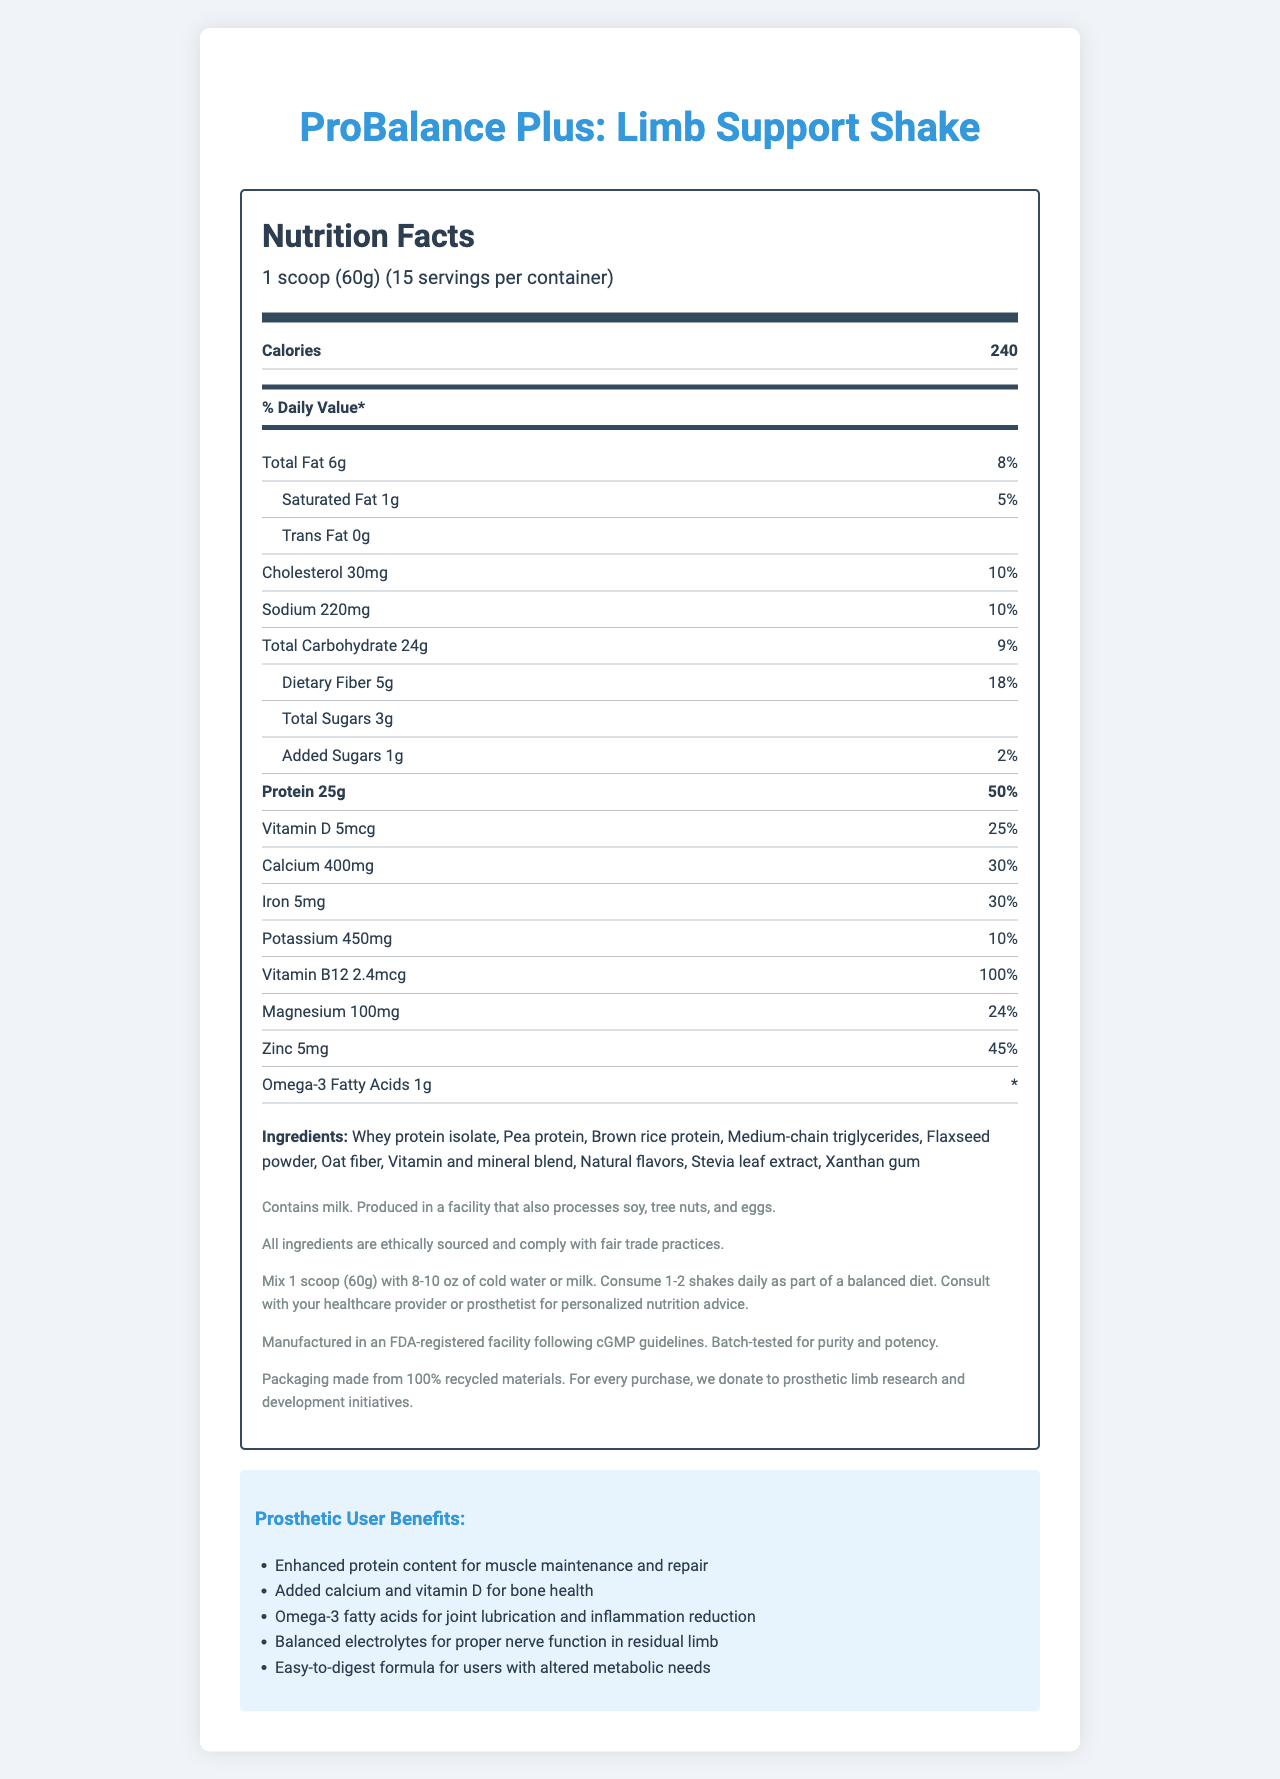how many servings are in the container? The document states that there are 15 servings per container.
Answer: 15 servings what is the main source of protein in the shake? The document lists whey protein isolate as the first ingredient, indicating it is the main source of protein.
Answer: Whey protein isolate how much dietary fiber is in one serving? The document lists dietary fiber as 5g per serving.
Answer: 5g what is the % daily value for calcium? The document indicates the daily value for calcium is 30%.
Answer: 30% which vitamin has the highest % daily value in the shake? The document shows that Vitamin B12 has a daily value of 100%.
Answer: Vitamin B12 how many calories are in one scoop of the shake? A. 180 B. 220 C. 240 D. 260 The document states that each serving (1 scoop) contains 240 calories.
Answer: C what amount of Omega-3 Fatty Acids is included in the shake? The document lists Omega-3 Fatty Acids as 1g per serving.
Answer: 1g how much sodium is in one serving of the shake? The document indicates that one serving contains 220mg of sodium.
Answer: 220mg which of the following medical benefits is not a listed benefit for prosthetic users? 
I. Enhanced protein content for muscle maintenance
II. Improved eyesight
III. Balanced electrolytes for nerve function
IV. Joint lubrication The document lists benefits for prosthetic users, but improved eyesight is not one of them.
Answer: II does the shake contain any allergens? The document states that the shake contains milk and is produced in a facility that processes soy, tree nuts, and eggs.
Answer: Yes is the packaging environmentally friendly? The document mentions that the packaging is made from 100% recycled materials.
Answer: Yes how should the shake be consumed according to usage instructions? The document provides the usage instructions, which state to mix 1 scoop with 8-10 oz of cold water or milk and consume 1-2 times daily.
Answer: Mix 1 scoop (60g) with 8-10 oz of cold water or milk can the exact amount of selenium in the shake be determined from the document? The document does not provide any information regarding the amount of selenium in the shake.
Answer: Not enough information summarize the key points of the "ProBalance Plus: Limb Support Shake" nourishment document. The document provides detailed nutritional information, ingredient list, allergen details, ethical sourcing, prosthetic user benefits, usage instructions, quality assurance, and sustainability efforts for the "ProBalance Plus: Limb Support Shake."
Answer: The "ProBalance Plus: Limb Support Shake" is a high-protein meal replacement designed for prosthetic limb users. It provides 240 calories per serving, with nutrients such as 25g of protein, 5g of dietary fiber, and 30% daily value of calcium. The shake contains ethically sourced ingredients like whey protein isolate and omega-3 fatty acids. Benefits for prosthetic users include muscle maintenance, bone health, and joint lubrication. The packaging is eco-friendly, and the product is allergen-aware and fair-trade compliant. 